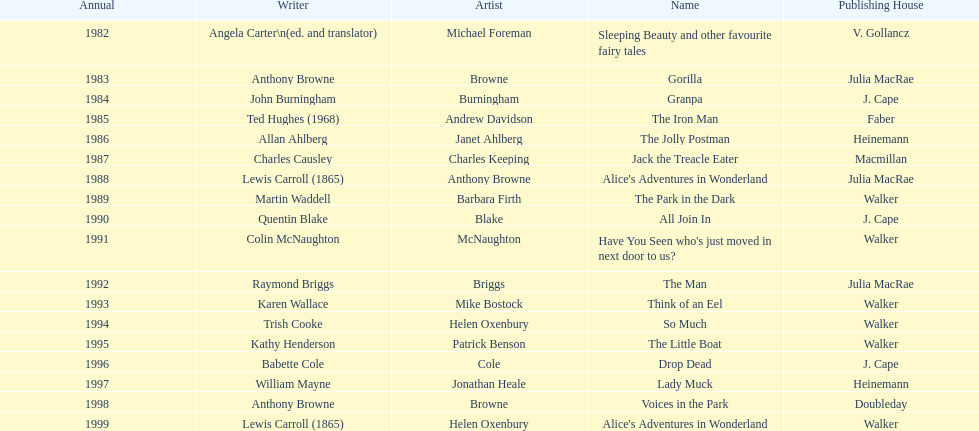Which other author, besides lewis carroll, has won the kurt maschler award twice? Anthony Browne. 